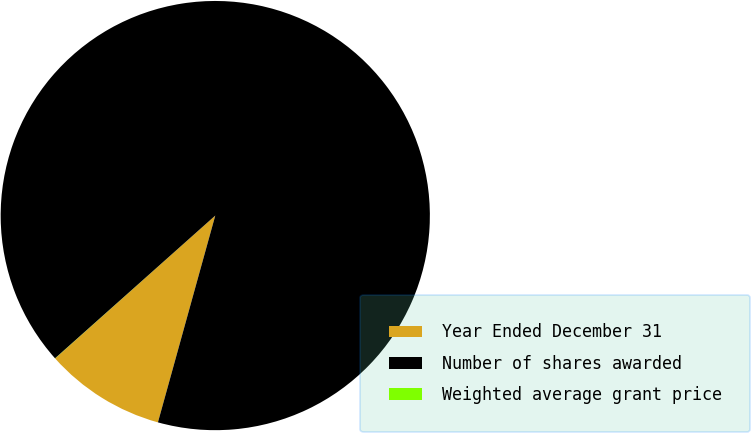<chart> <loc_0><loc_0><loc_500><loc_500><pie_chart><fcel>Year Ended December 31<fcel>Number of shares awarded<fcel>Weighted average grant price<nl><fcel>9.1%<fcel>90.89%<fcel>0.01%<nl></chart> 